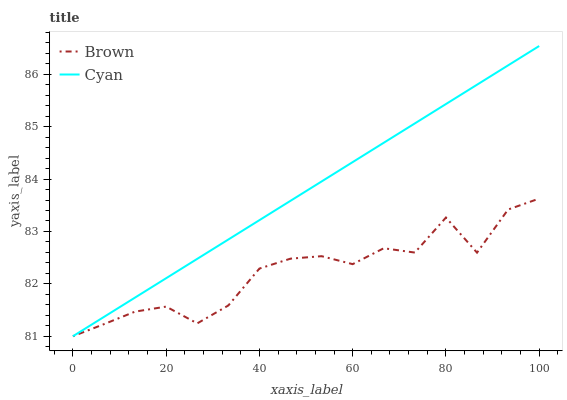Does Brown have the minimum area under the curve?
Answer yes or no. Yes. Does Cyan have the maximum area under the curve?
Answer yes or no. Yes. Does Cyan have the minimum area under the curve?
Answer yes or no. No. Is Cyan the smoothest?
Answer yes or no. Yes. Is Brown the roughest?
Answer yes or no. Yes. Is Cyan the roughest?
Answer yes or no. No. Does Cyan have the highest value?
Answer yes or no. Yes. 